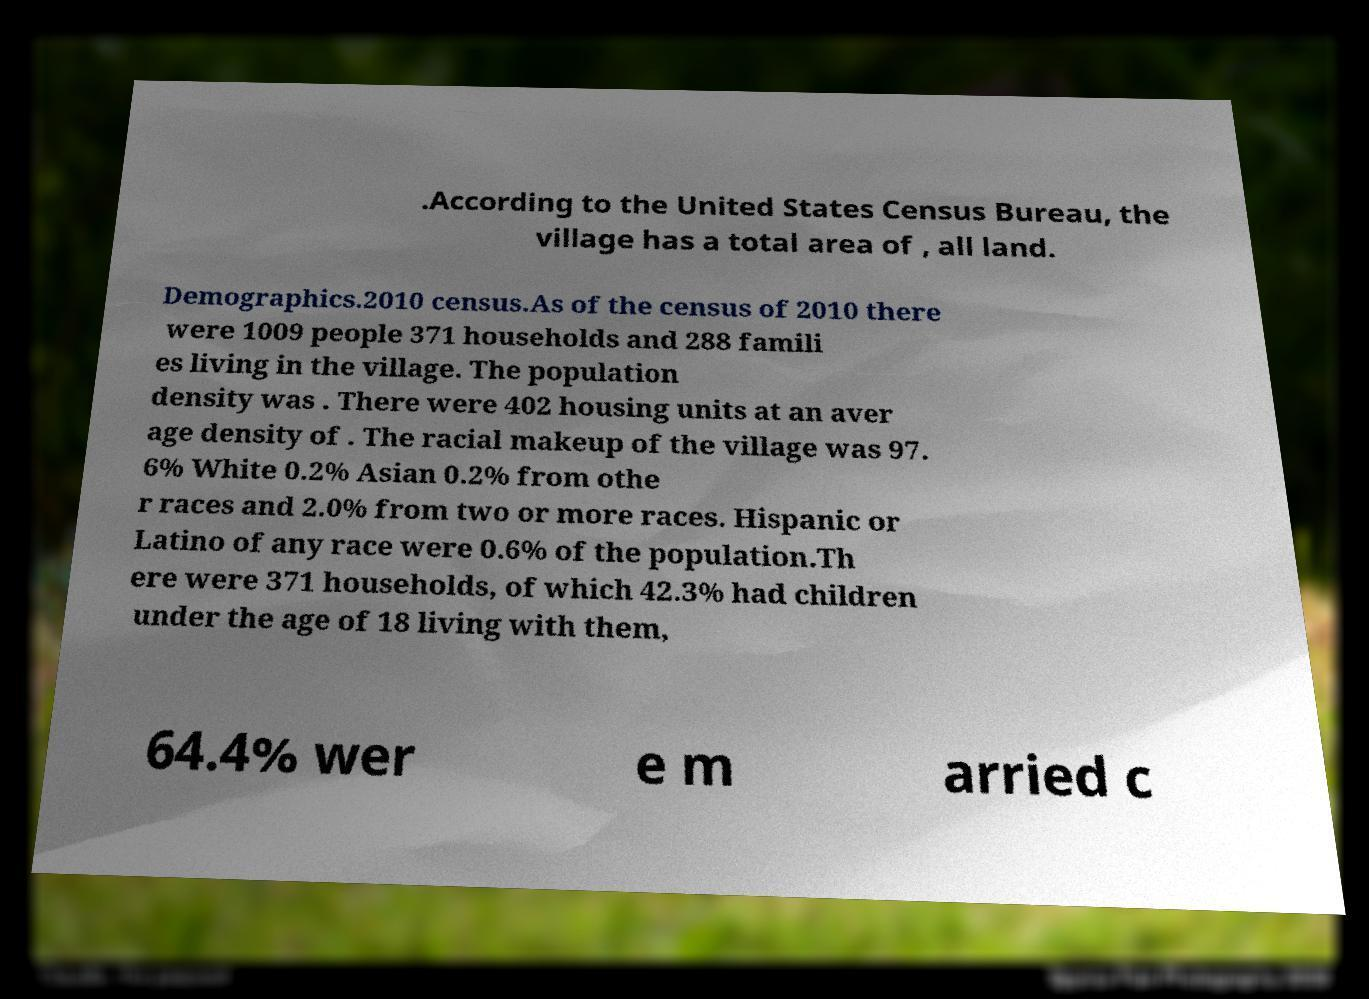Please read and relay the text visible in this image. What does it say? .According to the United States Census Bureau, the village has a total area of , all land. Demographics.2010 census.As of the census of 2010 there were 1009 people 371 households and 288 famili es living in the village. The population density was . There were 402 housing units at an aver age density of . The racial makeup of the village was 97. 6% White 0.2% Asian 0.2% from othe r races and 2.0% from two or more races. Hispanic or Latino of any race were 0.6% of the population.Th ere were 371 households, of which 42.3% had children under the age of 18 living with them, 64.4% wer e m arried c 